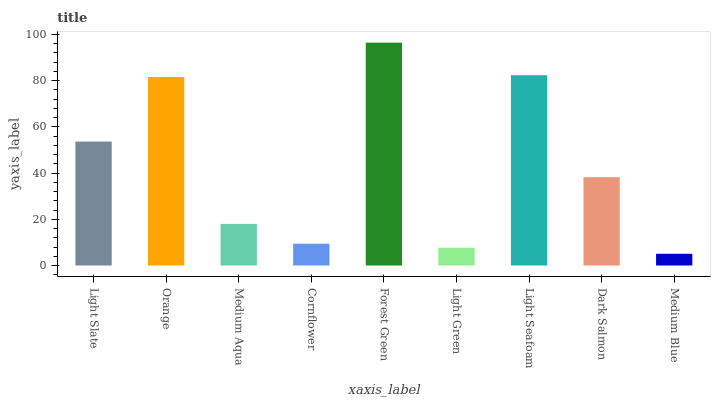Is Medium Blue the minimum?
Answer yes or no. Yes. Is Forest Green the maximum?
Answer yes or no. Yes. Is Orange the minimum?
Answer yes or no. No. Is Orange the maximum?
Answer yes or no. No. Is Orange greater than Light Slate?
Answer yes or no. Yes. Is Light Slate less than Orange?
Answer yes or no. Yes. Is Light Slate greater than Orange?
Answer yes or no. No. Is Orange less than Light Slate?
Answer yes or no. No. Is Dark Salmon the high median?
Answer yes or no. Yes. Is Dark Salmon the low median?
Answer yes or no. Yes. Is Light Seafoam the high median?
Answer yes or no. No. Is Forest Green the low median?
Answer yes or no. No. 